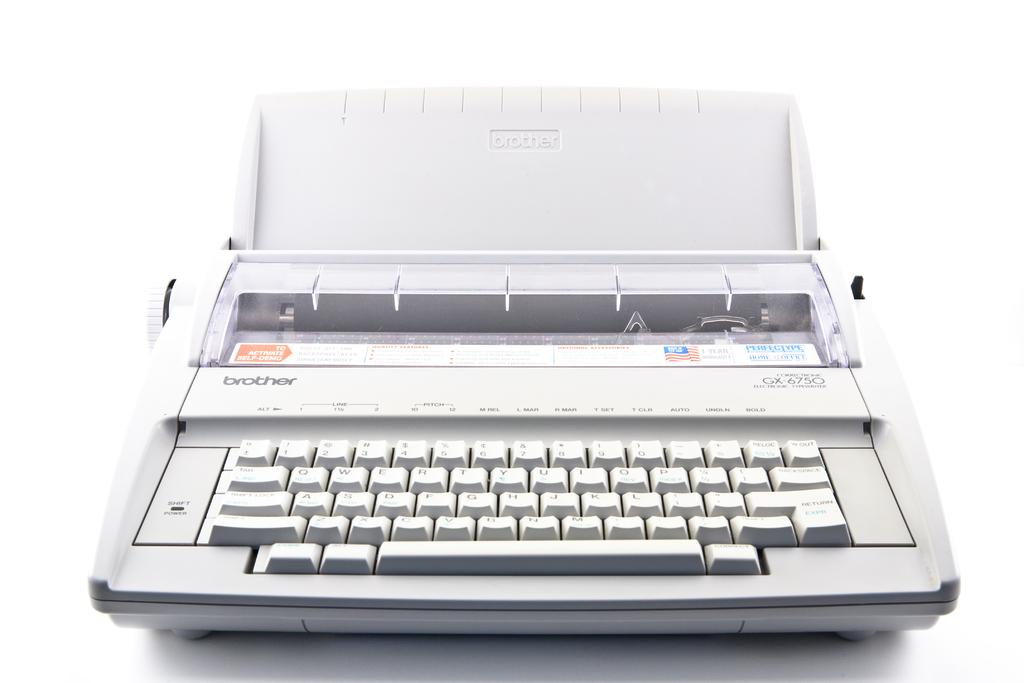Provide a one-sentence caption for the provided image. a white, Brother typewriter has no paper in it. 